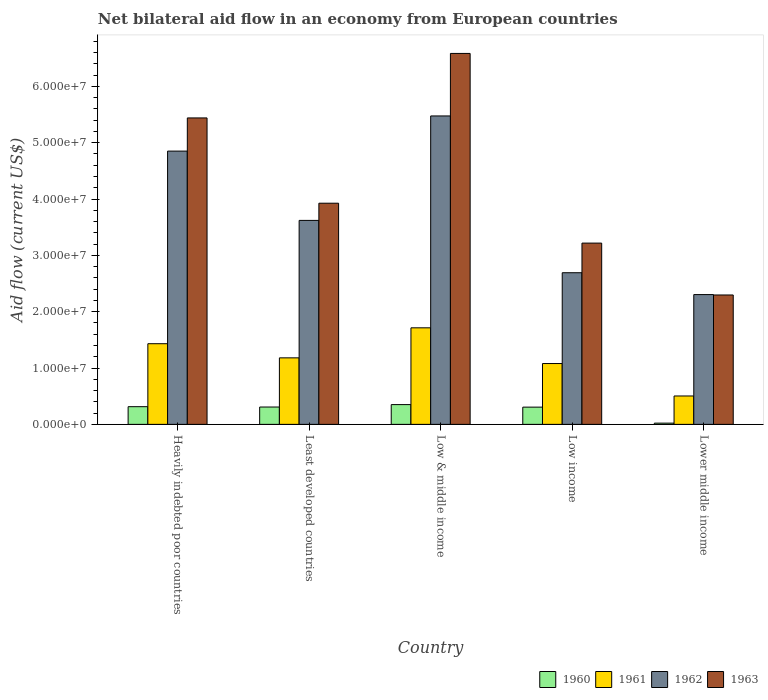How many different coloured bars are there?
Provide a short and direct response. 4. Are the number of bars per tick equal to the number of legend labels?
Provide a succinct answer. Yes. Are the number of bars on each tick of the X-axis equal?
Your response must be concise. Yes. How many bars are there on the 1st tick from the left?
Ensure brevity in your answer.  4. What is the label of the 5th group of bars from the left?
Give a very brief answer. Lower middle income. What is the net bilateral aid flow in 1960 in Low & middle income?
Ensure brevity in your answer.  3.51e+06. Across all countries, what is the maximum net bilateral aid flow in 1963?
Provide a succinct answer. 6.58e+07. Across all countries, what is the minimum net bilateral aid flow in 1960?
Offer a terse response. 2.20e+05. In which country was the net bilateral aid flow in 1961 minimum?
Ensure brevity in your answer.  Lower middle income. What is the total net bilateral aid flow in 1962 in the graph?
Ensure brevity in your answer.  1.89e+08. What is the difference between the net bilateral aid flow in 1962 in Least developed countries and that in Lower middle income?
Provide a succinct answer. 1.32e+07. What is the difference between the net bilateral aid flow in 1961 in Least developed countries and the net bilateral aid flow in 1962 in Low & middle income?
Your answer should be compact. -4.29e+07. What is the average net bilateral aid flow in 1961 per country?
Give a very brief answer. 1.18e+07. What is the difference between the net bilateral aid flow of/in 1962 and net bilateral aid flow of/in 1961 in Lower middle income?
Offer a very short reply. 1.80e+07. In how many countries, is the net bilateral aid flow in 1963 greater than 64000000 US$?
Provide a short and direct response. 1. What is the ratio of the net bilateral aid flow in 1960 in Low income to that in Lower middle income?
Your answer should be compact. 13.91. Is the net bilateral aid flow in 1961 in Low & middle income less than that in Low income?
Make the answer very short. No. Is the difference between the net bilateral aid flow in 1962 in Heavily indebted poor countries and Low & middle income greater than the difference between the net bilateral aid flow in 1961 in Heavily indebted poor countries and Low & middle income?
Ensure brevity in your answer.  No. What is the difference between the highest and the second highest net bilateral aid flow in 1962?
Your answer should be compact. 6.24e+06. What is the difference between the highest and the lowest net bilateral aid flow in 1961?
Make the answer very short. 1.21e+07. Is the sum of the net bilateral aid flow in 1962 in Low & middle income and Low income greater than the maximum net bilateral aid flow in 1960 across all countries?
Ensure brevity in your answer.  Yes. What does the 4th bar from the left in Low & middle income represents?
Give a very brief answer. 1963. What does the 1st bar from the right in Lower middle income represents?
Ensure brevity in your answer.  1963. What is the difference between two consecutive major ticks on the Y-axis?
Ensure brevity in your answer.  1.00e+07. Are the values on the major ticks of Y-axis written in scientific E-notation?
Provide a succinct answer. Yes. Does the graph contain any zero values?
Offer a very short reply. No. Does the graph contain grids?
Make the answer very short. No. Where does the legend appear in the graph?
Provide a succinct answer. Bottom right. How are the legend labels stacked?
Ensure brevity in your answer.  Horizontal. What is the title of the graph?
Your response must be concise. Net bilateral aid flow in an economy from European countries. Does "1987" appear as one of the legend labels in the graph?
Keep it short and to the point. No. What is the label or title of the Y-axis?
Provide a short and direct response. Aid flow (current US$). What is the Aid flow (current US$) of 1960 in Heavily indebted poor countries?
Offer a terse response. 3.14e+06. What is the Aid flow (current US$) of 1961 in Heavily indebted poor countries?
Give a very brief answer. 1.43e+07. What is the Aid flow (current US$) of 1962 in Heavily indebted poor countries?
Keep it short and to the point. 4.85e+07. What is the Aid flow (current US$) of 1963 in Heavily indebted poor countries?
Ensure brevity in your answer.  5.44e+07. What is the Aid flow (current US$) of 1960 in Least developed countries?
Provide a short and direct response. 3.08e+06. What is the Aid flow (current US$) in 1961 in Least developed countries?
Offer a terse response. 1.18e+07. What is the Aid flow (current US$) in 1962 in Least developed countries?
Offer a terse response. 3.62e+07. What is the Aid flow (current US$) in 1963 in Least developed countries?
Offer a terse response. 3.93e+07. What is the Aid flow (current US$) in 1960 in Low & middle income?
Your response must be concise. 3.51e+06. What is the Aid flow (current US$) in 1961 in Low & middle income?
Keep it short and to the point. 1.71e+07. What is the Aid flow (current US$) of 1962 in Low & middle income?
Your response must be concise. 5.48e+07. What is the Aid flow (current US$) in 1963 in Low & middle income?
Offer a very short reply. 6.58e+07. What is the Aid flow (current US$) in 1960 in Low income?
Your answer should be very brief. 3.06e+06. What is the Aid flow (current US$) in 1961 in Low income?
Offer a very short reply. 1.08e+07. What is the Aid flow (current US$) in 1962 in Low income?
Your answer should be compact. 2.69e+07. What is the Aid flow (current US$) of 1963 in Low income?
Offer a terse response. 3.22e+07. What is the Aid flow (current US$) of 1960 in Lower middle income?
Provide a succinct answer. 2.20e+05. What is the Aid flow (current US$) of 1961 in Lower middle income?
Keep it short and to the point. 5.04e+06. What is the Aid flow (current US$) of 1962 in Lower middle income?
Keep it short and to the point. 2.30e+07. What is the Aid flow (current US$) of 1963 in Lower middle income?
Offer a very short reply. 2.30e+07. Across all countries, what is the maximum Aid flow (current US$) in 1960?
Your answer should be compact. 3.51e+06. Across all countries, what is the maximum Aid flow (current US$) of 1961?
Keep it short and to the point. 1.71e+07. Across all countries, what is the maximum Aid flow (current US$) in 1962?
Offer a terse response. 5.48e+07. Across all countries, what is the maximum Aid flow (current US$) of 1963?
Provide a succinct answer. 6.58e+07. Across all countries, what is the minimum Aid flow (current US$) of 1961?
Offer a terse response. 5.04e+06. Across all countries, what is the minimum Aid flow (current US$) of 1962?
Your answer should be very brief. 2.30e+07. Across all countries, what is the minimum Aid flow (current US$) of 1963?
Offer a terse response. 2.30e+07. What is the total Aid flow (current US$) in 1960 in the graph?
Make the answer very short. 1.30e+07. What is the total Aid flow (current US$) in 1961 in the graph?
Provide a short and direct response. 5.91e+07. What is the total Aid flow (current US$) of 1962 in the graph?
Your answer should be compact. 1.89e+08. What is the total Aid flow (current US$) of 1963 in the graph?
Offer a terse response. 2.15e+08. What is the difference between the Aid flow (current US$) in 1960 in Heavily indebted poor countries and that in Least developed countries?
Offer a very short reply. 6.00e+04. What is the difference between the Aid flow (current US$) in 1961 in Heavily indebted poor countries and that in Least developed countries?
Give a very brief answer. 2.51e+06. What is the difference between the Aid flow (current US$) in 1962 in Heavily indebted poor countries and that in Least developed countries?
Your answer should be very brief. 1.23e+07. What is the difference between the Aid flow (current US$) in 1963 in Heavily indebted poor countries and that in Least developed countries?
Provide a short and direct response. 1.51e+07. What is the difference between the Aid flow (current US$) of 1960 in Heavily indebted poor countries and that in Low & middle income?
Make the answer very short. -3.70e+05. What is the difference between the Aid flow (current US$) of 1961 in Heavily indebted poor countries and that in Low & middle income?
Your response must be concise. -2.82e+06. What is the difference between the Aid flow (current US$) in 1962 in Heavily indebted poor countries and that in Low & middle income?
Provide a succinct answer. -6.24e+06. What is the difference between the Aid flow (current US$) in 1963 in Heavily indebted poor countries and that in Low & middle income?
Offer a very short reply. -1.14e+07. What is the difference between the Aid flow (current US$) of 1960 in Heavily indebted poor countries and that in Low income?
Your answer should be compact. 8.00e+04. What is the difference between the Aid flow (current US$) of 1961 in Heavily indebted poor countries and that in Low income?
Your answer should be compact. 3.52e+06. What is the difference between the Aid flow (current US$) of 1962 in Heavily indebted poor countries and that in Low income?
Ensure brevity in your answer.  2.16e+07. What is the difference between the Aid flow (current US$) in 1963 in Heavily indebted poor countries and that in Low income?
Your response must be concise. 2.22e+07. What is the difference between the Aid flow (current US$) of 1960 in Heavily indebted poor countries and that in Lower middle income?
Your answer should be very brief. 2.92e+06. What is the difference between the Aid flow (current US$) in 1961 in Heavily indebted poor countries and that in Lower middle income?
Offer a terse response. 9.28e+06. What is the difference between the Aid flow (current US$) of 1962 in Heavily indebted poor countries and that in Lower middle income?
Your response must be concise. 2.55e+07. What is the difference between the Aid flow (current US$) in 1963 in Heavily indebted poor countries and that in Lower middle income?
Provide a short and direct response. 3.14e+07. What is the difference between the Aid flow (current US$) of 1960 in Least developed countries and that in Low & middle income?
Your answer should be very brief. -4.30e+05. What is the difference between the Aid flow (current US$) of 1961 in Least developed countries and that in Low & middle income?
Give a very brief answer. -5.33e+06. What is the difference between the Aid flow (current US$) of 1962 in Least developed countries and that in Low & middle income?
Give a very brief answer. -1.85e+07. What is the difference between the Aid flow (current US$) in 1963 in Least developed countries and that in Low & middle income?
Make the answer very short. -2.66e+07. What is the difference between the Aid flow (current US$) of 1961 in Least developed countries and that in Low income?
Your answer should be very brief. 1.01e+06. What is the difference between the Aid flow (current US$) of 1962 in Least developed countries and that in Low income?
Provide a short and direct response. 9.29e+06. What is the difference between the Aid flow (current US$) in 1963 in Least developed countries and that in Low income?
Your answer should be very brief. 7.08e+06. What is the difference between the Aid flow (current US$) of 1960 in Least developed countries and that in Lower middle income?
Your answer should be very brief. 2.86e+06. What is the difference between the Aid flow (current US$) in 1961 in Least developed countries and that in Lower middle income?
Ensure brevity in your answer.  6.77e+06. What is the difference between the Aid flow (current US$) in 1962 in Least developed countries and that in Lower middle income?
Offer a very short reply. 1.32e+07. What is the difference between the Aid flow (current US$) of 1963 in Least developed countries and that in Lower middle income?
Provide a short and direct response. 1.63e+07. What is the difference between the Aid flow (current US$) in 1961 in Low & middle income and that in Low income?
Your response must be concise. 6.34e+06. What is the difference between the Aid flow (current US$) in 1962 in Low & middle income and that in Low income?
Offer a terse response. 2.78e+07. What is the difference between the Aid flow (current US$) in 1963 in Low & middle income and that in Low income?
Give a very brief answer. 3.37e+07. What is the difference between the Aid flow (current US$) of 1960 in Low & middle income and that in Lower middle income?
Ensure brevity in your answer.  3.29e+06. What is the difference between the Aid flow (current US$) of 1961 in Low & middle income and that in Lower middle income?
Your answer should be very brief. 1.21e+07. What is the difference between the Aid flow (current US$) in 1962 in Low & middle income and that in Lower middle income?
Offer a very short reply. 3.17e+07. What is the difference between the Aid flow (current US$) of 1963 in Low & middle income and that in Lower middle income?
Your response must be concise. 4.29e+07. What is the difference between the Aid flow (current US$) in 1960 in Low income and that in Lower middle income?
Your answer should be compact. 2.84e+06. What is the difference between the Aid flow (current US$) of 1961 in Low income and that in Lower middle income?
Your answer should be compact. 5.76e+06. What is the difference between the Aid flow (current US$) of 1962 in Low income and that in Lower middle income?
Provide a succinct answer. 3.88e+06. What is the difference between the Aid flow (current US$) of 1963 in Low income and that in Lower middle income?
Your response must be concise. 9.21e+06. What is the difference between the Aid flow (current US$) in 1960 in Heavily indebted poor countries and the Aid flow (current US$) in 1961 in Least developed countries?
Offer a terse response. -8.67e+06. What is the difference between the Aid flow (current US$) of 1960 in Heavily indebted poor countries and the Aid flow (current US$) of 1962 in Least developed countries?
Keep it short and to the point. -3.31e+07. What is the difference between the Aid flow (current US$) of 1960 in Heavily indebted poor countries and the Aid flow (current US$) of 1963 in Least developed countries?
Provide a succinct answer. -3.61e+07. What is the difference between the Aid flow (current US$) in 1961 in Heavily indebted poor countries and the Aid flow (current US$) in 1962 in Least developed countries?
Your answer should be compact. -2.19e+07. What is the difference between the Aid flow (current US$) of 1961 in Heavily indebted poor countries and the Aid flow (current US$) of 1963 in Least developed countries?
Provide a short and direct response. -2.49e+07. What is the difference between the Aid flow (current US$) of 1962 in Heavily indebted poor countries and the Aid flow (current US$) of 1963 in Least developed countries?
Offer a very short reply. 9.25e+06. What is the difference between the Aid flow (current US$) in 1960 in Heavily indebted poor countries and the Aid flow (current US$) in 1961 in Low & middle income?
Offer a terse response. -1.40e+07. What is the difference between the Aid flow (current US$) of 1960 in Heavily indebted poor countries and the Aid flow (current US$) of 1962 in Low & middle income?
Offer a terse response. -5.16e+07. What is the difference between the Aid flow (current US$) of 1960 in Heavily indebted poor countries and the Aid flow (current US$) of 1963 in Low & middle income?
Offer a terse response. -6.27e+07. What is the difference between the Aid flow (current US$) in 1961 in Heavily indebted poor countries and the Aid flow (current US$) in 1962 in Low & middle income?
Offer a terse response. -4.04e+07. What is the difference between the Aid flow (current US$) of 1961 in Heavily indebted poor countries and the Aid flow (current US$) of 1963 in Low & middle income?
Your answer should be very brief. -5.15e+07. What is the difference between the Aid flow (current US$) of 1962 in Heavily indebted poor countries and the Aid flow (current US$) of 1963 in Low & middle income?
Give a very brief answer. -1.73e+07. What is the difference between the Aid flow (current US$) in 1960 in Heavily indebted poor countries and the Aid flow (current US$) in 1961 in Low income?
Keep it short and to the point. -7.66e+06. What is the difference between the Aid flow (current US$) of 1960 in Heavily indebted poor countries and the Aid flow (current US$) of 1962 in Low income?
Offer a very short reply. -2.38e+07. What is the difference between the Aid flow (current US$) in 1960 in Heavily indebted poor countries and the Aid flow (current US$) in 1963 in Low income?
Keep it short and to the point. -2.90e+07. What is the difference between the Aid flow (current US$) in 1961 in Heavily indebted poor countries and the Aid flow (current US$) in 1962 in Low income?
Ensure brevity in your answer.  -1.26e+07. What is the difference between the Aid flow (current US$) of 1961 in Heavily indebted poor countries and the Aid flow (current US$) of 1963 in Low income?
Ensure brevity in your answer.  -1.79e+07. What is the difference between the Aid flow (current US$) in 1962 in Heavily indebted poor countries and the Aid flow (current US$) in 1963 in Low income?
Offer a very short reply. 1.63e+07. What is the difference between the Aid flow (current US$) in 1960 in Heavily indebted poor countries and the Aid flow (current US$) in 1961 in Lower middle income?
Give a very brief answer. -1.90e+06. What is the difference between the Aid flow (current US$) in 1960 in Heavily indebted poor countries and the Aid flow (current US$) in 1962 in Lower middle income?
Keep it short and to the point. -1.99e+07. What is the difference between the Aid flow (current US$) of 1960 in Heavily indebted poor countries and the Aid flow (current US$) of 1963 in Lower middle income?
Ensure brevity in your answer.  -1.98e+07. What is the difference between the Aid flow (current US$) of 1961 in Heavily indebted poor countries and the Aid flow (current US$) of 1962 in Lower middle income?
Offer a very short reply. -8.72e+06. What is the difference between the Aid flow (current US$) in 1961 in Heavily indebted poor countries and the Aid flow (current US$) in 1963 in Lower middle income?
Provide a short and direct response. -8.65e+06. What is the difference between the Aid flow (current US$) in 1962 in Heavily indebted poor countries and the Aid flow (current US$) in 1963 in Lower middle income?
Make the answer very short. 2.55e+07. What is the difference between the Aid flow (current US$) in 1960 in Least developed countries and the Aid flow (current US$) in 1961 in Low & middle income?
Provide a succinct answer. -1.41e+07. What is the difference between the Aid flow (current US$) in 1960 in Least developed countries and the Aid flow (current US$) in 1962 in Low & middle income?
Your answer should be compact. -5.17e+07. What is the difference between the Aid flow (current US$) in 1960 in Least developed countries and the Aid flow (current US$) in 1963 in Low & middle income?
Your answer should be compact. -6.28e+07. What is the difference between the Aid flow (current US$) in 1961 in Least developed countries and the Aid flow (current US$) in 1962 in Low & middle income?
Provide a succinct answer. -4.29e+07. What is the difference between the Aid flow (current US$) of 1961 in Least developed countries and the Aid flow (current US$) of 1963 in Low & middle income?
Make the answer very short. -5.40e+07. What is the difference between the Aid flow (current US$) in 1962 in Least developed countries and the Aid flow (current US$) in 1963 in Low & middle income?
Ensure brevity in your answer.  -2.96e+07. What is the difference between the Aid flow (current US$) in 1960 in Least developed countries and the Aid flow (current US$) in 1961 in Low income?
Your answer should be very brief. -7.72e+06. What is the difference between the Aid flow (current US$) of 1960 in Least developed countries and the Aid flow (current US$) of 1962 in Low income?
Provide a short and direct response. -2.38e+07. What is the difference between the Aid flow (current US$) of 1960 in Least developed countries and the Aid flow (current US$) of 1963 in Low income?
Your answer should be compact. -2.91e+07. What is the difference between the Aid flow (current US$) in 1961 in Least developed countries and the Aid flow (current US$) in 1962 in Low income?
Ensure brevity in your answer.  -1.51e+07. What is the difference between the Aid flow (current US$) of 1961 in Least developed countries and the Aid flow (current US$) of 1963 in Low income?
Offer a very short reply. -2.04e+07. What is the difference between the Aid flow (current US$) of 1962 in Least developed countries and the Aid flow (current US$) of 1963 in Low income?
Your answer should be very brief. 4.03e+06. What is the difference between the Aid flow (current US$) in 1960 in Least developed countries and the Aid flow (current US$) in 1961 in Lower middle income?
Offer a terse response. -1.96e+06. What is the difference between the Aid flow (current US$) in 1960 in Least developed countries and the Aid flow (current US$) in 1962 in Lower middle income?
Provide a short and direct response. -2.00e+07. What is the difference between the Aid flow (current US$) in 1960 in Least developed countries and the Aid flow (current US$) in 1963 in Lower middle income?
Provide a short and direct response. -1.99e+07. What is the difference between the Aid flow (current US$) in 1961 in Least developed countries and the Aid flow (current US$) in 1962 in Lower middle income?
Your response must be concise. -1.12e+07. What is the difference between the Aid flow (current US$) of 1961 in Least developed countries and the Aid flow (current US$) of 1963 in Lower middle income?
Your response must be concise. -1.12e+07. What is the difference between the Aid flow (current US$) of 1962 in Least developed countries and the Aid flow (current US$) of 1963 in Lower middle income?
Keep it short and to the point. 1.32e+07. What is the difference between the Aid flow (current US$) in 1960 in Low & middle income and the Aid flow (current US$) in 1961 in Low income?
Give a very brief answer. -7.29e+06. What is the difference between the Aid flow (current US$) of 1960 in Low & middle income and the Aid flow (current US$) of 1962 in Low income?
Your answer should be very brief. -2.34e+07. What is the difference between the Aid flow (current US$) in 1960 in Low & middle income and the Aid flow (current US$) in 1963 in Low income?
Make the answer very short. -2.87e+07. What is the difference between the Aid flow (current US$) of 1961 in Low & middle income and the Aid flow (current US$) of 1962 in Low income?
Ensure brevity in your answer.  -9.78e+06. What is the difference between the Aid flow (current US$) of 1961 in Low & middle income and the Aid flow (current US$) of 1963 in Low income?
Ensure brevity in your answer.  -1.50e+07. What is the difference between the Aid flow (current US$) of 1962 in Low & middle income and the Aid flow (current US$) of 1963 in Low income?
Your answer should be very brief. 2.26e+07. What is the difference between the Aid flow (current US$) of 1960 in Low & middle income and the Aid flow (current US$) of 1961 in Lower middle income?
Your answer should be very brief. -1.53e+06. What is the difference between the Aid flow (current US$) of 1960 in Low & middle income and the Aid flow (current US$) of 1962 in Lower middle income?
Keep it short and to the point. -1.95e+07. What is the difference between the Aid flow (current US$) of 1960 in Low & middle income and the Aid flow (current US$) of 1963 in Lower middle income?
Provide a short and direct response. -1.95e+07. What is the difference between the Aid flow (current US$) in 1961 in Low & middle income and the Aid flow (current US$) in 1962 in Lower middle income?
Offer a very short reply. -5.90e+06. What is the difference between the Aid flow (current US$) of 1961 in Low & middle income and the Aid flow (current US$) of 1963 in Lower middle income?
Your answer should be very brief. -5.83e+06. What is the difference between the Aid flow (current US$) of 1962 in Low & middle income and the Aid flow (current US$) of 1963 in Lower middle income?
Your response must be concise. 3.18e+07. What is the difference between the Aid flow (current US$) of 1960 in Low income and the Aid flow (current US$) of 1961 in Lower middle income?
Your answer should be very brief. -1.98e+06. What is the difference between the Aid flow (current US$) of 1960 in Low income and the Aid flow (current US$) of 1962 in Lower middle income?
Keep it short and to the point. -2.00e+07. What is the difference between the Aid flow (current US$) in 1960 in Low income and the Aid flow (current US$) in 1963 in Lower middle income?
Give a very brief answer. -1.99e+07. What is the difference between the Aid flow (current US$) of 1961 in Low income and the Aid flow (current US$) of 1962 in Lower middle income?
Provide a succinct answer. -1.22e+07. What is the difference between the Aid flow (current US$) in 1961 in Low income and the Aid flow (current US$) in 1963 in Lower middle income?
Your answer should be compact. -1.22e+07. What is the difference between the Aid flow (current US$) in 1962 in Low income and the Aid flow (current US$) in 1963 in Lower middle income?
Make the answer very short. 3.95e+06. What is the average Aid flow (current US$) in 1960 per country?
Keep it short and to the point. 2.60e+06. What is the average Aid flow (current US$) in 1961 per country?
Give a very brief answer. 1.18e+07. What is the average Aid flow (current US$) of 1962 per country?
Your answer should be compact. 3.79e+07. What is the average Aid flow (current US$) of 1963 per country?
Offer a terse response. 4.29e+07. What is the difference between the Aid flow (current US$) in 1960 and Aid flow (current US$) in 1961 in Heavily indebted poor countries?
Make the answer very short. -1.12e+07. What is the difference between the Aid flow (current US$) in 1960 and Aid flow (current US$) in 1962 in Heavily indebted poor countries?
Your response must be concise. -4.54e+07. What is the difference between the Aid flow (current US$) of 1960 and Aid flow (current US$) of 1963 in Heavily indebted poor countries?
Offer a terse response. -5.13e+07. What is the difference between the Aid flow (current US$) of 1961 and Aid flow (current US$) of 1962 in Heavily indebted poor countries?
Your answer should be compact. -3.42e+07. What is the difference between the Aid flow (current US$) of 1961 and Aid flow (current US$) of 1963 in Heavily indebted poor countries?
Offer a very short reply. -4.01e+07. What is the difference between the Aid flow (current US$) of 1962 and Aid flow (current US$) of 1963 in Heavily indebted poor countries?
Offer a terse response. -5.89e+06. What is the difference between the Aid flow (current US$) of 1960 and Aid flow (current US$) of 1961 in Least developed countries?
Give a very brief answer. -8.73e+06. What is the difference between the Aid flow (current US$) in 1960 and Aid flow (current US$) in 1962 in Least developed countries?
Ensure brevity in your answer.  -3.31e+07. What is the difference between the Aid flow (current US$) of 1960 and Aid flow (current US$) of 1963 in Least developed countries?
Your answer should be compact. -3.62e+07. What is the difference between the Aid flow (current US$) of 1961 and Aid flow (current US$) of 1962 in Least developed countries?
Keep it short and to the point. -2.44e+07. What is the difference between the Aid flow (current US$) in 1961 and Aid flow (current US$) in 1963 in Least developed countries?
Make the answer very short. -2.74e+07. What is the difference between the Aid flow (current US$) of 1962 and Aid flow (current US$) of 1963 in Least developed countries?
Keep it short and to the point. -3.05e+06. What is the difference between the Aid flow (current US$) in 1960 and Aid flow (current US$) in 1961 in Low & middle income?
Offer a terse response. -1.36e+07. What is the difference between the Aid flow (current US$) in 1960 and Aid flow (current US$) in 1962 in Low & middle income?
Give a very brief answer. -5.12e+07. What is the difference between the Aid flow (current US$) in 1960 and Aid flow (current US$) in 1963 in Low & middle income?
Your answer should be compact. -6.23e+07. What is the difference between the Aid flow (current US$) in 1961 and Aid flow (current US$) in 1962 in Low & middle income?
Your response must be concise. -3.76e+07. What is the difference between the Aid flow (current US$) in 1961 and Aid flow (current US$) in 1963 in Low & middle income?
Offer a terse response. -4.87e+07. What is the difference between the Aid flow (current US$) in 1962 and Aid flow (current US$) in 1963 in Low & middle income?
Keep it short and to the point. -1.11e+07. What is the difference between the Aid flow (current US$) of 1960 and Aid flow (current US$) of 1961 in Low income?
Your answer should be very brief. -7.74e+06. What is the difference between the Aid flow (current US$) of 1960 and Aid flow (current US$) of 1962 in Low income?
Make the answer very short. -2.39e+07. What is the difference between the Aid flow (current US$) of 1960 and Aid flow (current US$) of 1963 in Low income?
Provide a short and direct response. -2.91e+07. What is the difference between the Aid flow (current US$) of 1961 and Aid flow (current US$) of 1962 in Low income?
Your answer should be very brief. -1.61e+07. What is the difference between the Aid flow (current US$) in 1961 and Aid flow (current US$) in 1963 in Low income?
Your answer should be very brief. -2.14e+07. What is the difference between the Aid flow (current US$) of 1962 and Aid flow (current US$) of 1963 in Low income?
Offer a terse response. -5.26e+06. What is the difference between the Aid flow (current US$) of 1960 and Aid flow (current US$) of 1961 in Lower middle income?
Offer a very short reply. -4.82e+06. What is the difference between the Aid flow (current US$) in 1960 and Aid flow (current US$) in 1962 in Lower middle income?
Keep it short and to the point. -2.28e+07. What is the difference between the Aid flow (current US$) of 1960 and Aid flow (current US$) of 1963 in Lower middle income?
Your answer should be very brief. -2.28e+07. What is the difference between the Aid flow (current US$) in 1961 and Aid flow (current US$) in 1962 in Lower middle income?
Provide a short and direct response. -1.80e+07. What is the difference between the Aid flow (current US$) in 1961 and Aid flow (current US$) in 1963 in Lower middle income?
Your answer should be compact. -1.79e+07. What is the difference between the Aid flow (current US$) of 1962 and Aid flow (current US$) of 1963 in Lower middle income?
Your response must be concise. 7.00e+04. What is the ratio of the Aid flow (current US$) of 1960 in Heavily indebted poor countries to that in Least developed countries?
Keep it short and to the point. 1.02. What is the ratio of the Aid flow (current US$) of 1961 in Heavily indebted poor countries to that in Least developed countries?
Give a very brief answer. 1.21. What is the ratio of the Aid flow (current US$) of 1962 in Heavily indebted poor countries to that in Least developed countries?
Provide a short and direct response. 1.34. What is the ratio of the Aid flow (current US$) in 1963 in Heavily indebted poor countries to that in Least developed countries?
Keep it short and to the point. 1.39. What is the ratio of the Aid flow (current US$) in 1960 in Heavily indebted poor countries to that in Low & middle income?
Offer a terse response. 0.89. What is the ratio of the Aid flow (current US$) in 1961 in Heavily indebted poor countries to that in Low & middle income?
Provide a short and direct response. 0.84. What is the ratio of the Aid flow (current US$) of 1962 in Heavily indebted poor countries to that in Low & middle income?
Your answer should be very brief. 0.89. What is the ratio of the Aid flow (current US$) in 1963 in Heavily indebted poor countries to that in Low & middle income?
Keep it short and to the point. 0.83. What is the ratio of the Aid flow (current US$) of 1960 in Heavily indebted poor countries to that in Low income?
Offer a very short reply. 1.03. What is the ratio of the Aid flow (current US$) in 1961 in Heavily indebted poor countries to that in Low income?
Keep it short and to the point. 1.33. What is the ratio of the Aid flow (current US$) of 1962 in Heavily indebted poor countries to that in Low income?
Provide a short and direct response. 1.8. What is the ratio of the Aid flow (current US$) of 1963 in Heavily indebted poor countries to that in Low income?
Provide a succinct answer. 1.69. What is the ratio of the Aid flow (current US$) of 1960 in Heavily indebted poor countries to that in Lower middle income?
Your answer should be compact. 14.27. What is the ratio of the Aid flow (current US$) in 1961 in Heavily indebted poor countries to that in Lower middle income?
Provide a succinct answer. 2.84. What is the ratio of the Aid flow (current US$) of 1962 in Heavily indebted poor countries to that in Lower middle income?
Your answer should be very brief. 2.11. What is the ratio of the Aid flow (current US$) in 1963 in Heavily indebted poor countries to that in Lower middle income?
Provide a short and direct response. 2.37. What is the ratio of the Aid flow (current US$) of 1960 in Least developed countries to that in Low & middle income?
Offer a terse response. 0.88. What is the ratio of the Aid flow (current US$) of 1961 in Least developed countries to that in Low & middle income?
Provide a succinct answer. 0.69. What is the ratio of the Aid flow (current US$) in 1962 in Least developed countries to that in Low & middle income?
Keep it short and to the point. 0.66. What is the ratio of the Aid flow (current US$) in 1963 in Least developed countries to that in Low & middle income?
Your answer should be compact. 0.6. What is the ratio of the Aid flow (current US$) of 1961 in Least developed countries to that in Low income?
Your answer should be very brief. 1.09. What is the ratio of the Aid flow (current US$) in 1962 in Least developed countries to that in Low income?
Keep it short and to the point. 1.35. What is the ratio of the Aid flow (current US$) of 1963 in Least developed countries to that in Low income?
Give a very brief answer. 1.22. What is the ratio of the Aid flow (current US$) in 1961 in Least developed countries to that in Lower middle income?
Offer a terse response. 2.34. What is the ratio of the Aid flow (current US$) in 1962 in Least developed countries to that in Lower middle income?
Your response must be concise. 1.57. What is the ratio of the Aid flow (current US$) in 1963 in Least developed countries to that in Lower middle income?
Offer a terse response. 1.71. What is the ratio of the Aid flow (current US$) in 1960 in Low & middle income to that in Low income?
Provide a short and direct response. 1.15. What is the ratio of the Aid flow (current US$) of 1961 in Low & middle income to that in Low income?
Offer a terse response. 1.59. What is the ratio of the Aid flow (current US$) in 1962 in Low & middle income to that in Low income?
Your response must be concise. 2.03. What is the ratio of the Aid flow (current US$) in 1963 in Low & middle income to that in Low income?
Offer a terse response. 2.05. What is the ratio of the Aid flow (current US$) in 1960 in Low & middle income to that in Lower middle income?
Offer a terse response. 15.95. What is the ratio of the Aid flow (current US$) of 1961 in Low & middle income to that in Lower middle income?
Ensure brevity in your answer.  3.4. What is the ratio of the Aid flow (current US$) of 1962 in Low & middle income to that in Lower middle income?
Give a very brief answer. 2.38. What is the ratio of the Aid flow (current US$) of 1963 in Low & middle income to that in Lower middle income?
Your answer should be very brief. 2.87. What is the ratio of the Aid flow (current US$) in 1960 in Low income to that in Lower middle income?
Your answer should be compact. 13.91. What is the ratio of the Aid flow (current US$) of 1961 in Low income to that in Lower middle income?
Keep it short and to the point. 2.14. What is the ratio of the Aid flow (current US$) of 1962 in Low income to that in Lower middle income?
Keep it short and to the point. 1.17. What is the ratio of the Aid flow (current US$) of 1963 in Low income to that in Lower middle income?
Offer a very short reply. 1.4. What is the difference between the highest and the second highest Aid flow (current US$) of 1961?
Your answer should be very brief. 2.82e+06. What is the difference between the highest and the second highest Aid flow (current US$) of 1962?
Your answer should be compact. 6.24e+06. What is the difference between the highest and the second highest Aid flow (current US$) of 1963?
Give a very brief answer. 1.14e+07. What is the difference between the highest and the lowest Aid flow (current US$) of 1960?
Keep it short and to the point. 3.29e+06. What is the difference between the highest and the lowest Aid flow (current US$) in 1961?
Offer a terse response. 1.21e+07. What is the difference between the highest and the lowest Aid flow (current US$) in 1962?
Your response must be concise. 3.17e+07. What is the difference between the highest and the lowest Aid flow (current US$) in 1963?
Offer a terse response. 4.29e+07. 